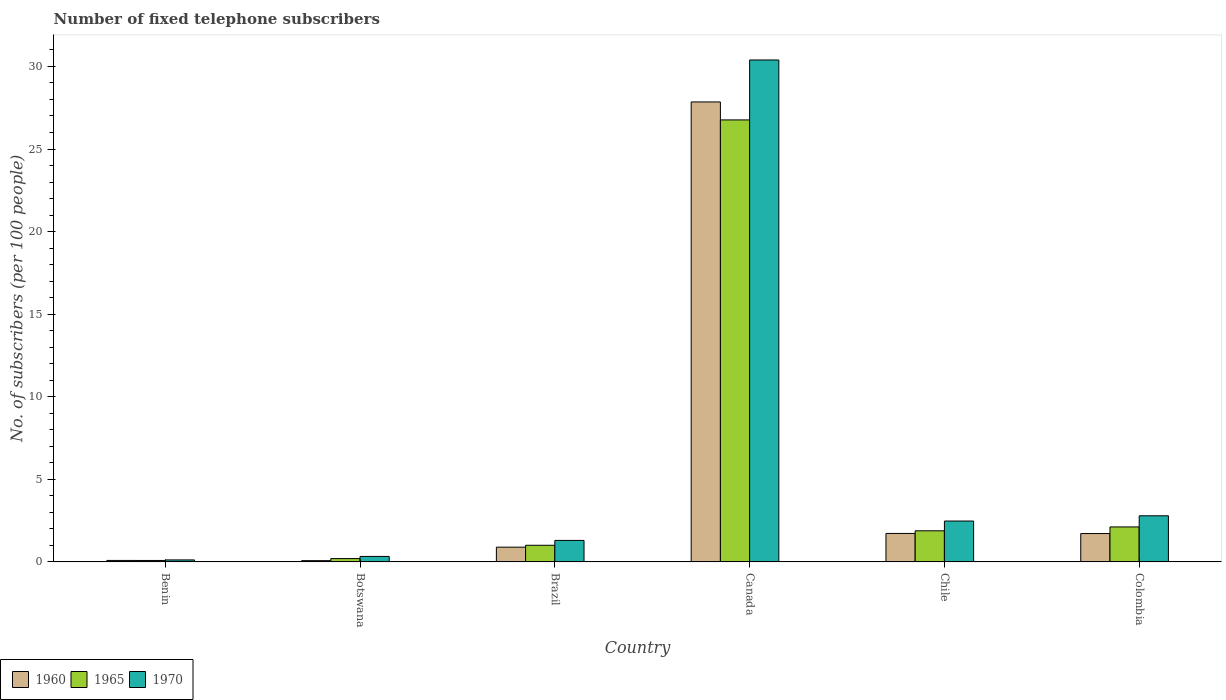How many bars are there on the 4th tick from the right?
Your response must be concise. 3. In how many cases, is the number of bars for a given country not equal to the number of legend labels?
Your answer should be very brief. 0. What is the number of fixed telephone subscribers in 1965 in Benin?
Your response must be concise. 0.09. Across all countries, what is the maximum number of fixed telephone subscribers in 1970?
Offer a very short reply. 30.39. Across all countries, what is the minimum number of fixed telephone subscribers in 1970?
Ensure brevity in your answer.  0.12. In which country was the number of fixed telephone subscribers in 1965 maximum?
Your response must be concise. Canada. In which country was the number of fixed telephone subscribers in 1970 minimum?
Provide a short and direct response. Benin. What is the total number of fixed telephone subscribers in 1965 in the graph?
Provide a short and direct response. 32.06. What is the difference between the number of fixed telephone subscribers in 1965 in Brazil and that in Colombia?
Offer a very short reply. -1.11. What is the difference between the number of fixed telephone subscribers in 1965 in Brazil and the number of fixed telephone subscribers in 1960 in Benin?
Give a very brief answer. 0.92. What is the average number of fixed telephone subscribers in 1970 per country?
Your answer should be very brief. 6.24. What is the difference between the number of fixed telephone subscribers of/in 1970 and number of fixed telephone subscribers of/in 1965 in Colombia?
Keep it short and to the point. 0.67. In how many countries, is the number of fixed telephone subscribers in 1965 greater than 15?
Your answer should be very brief. 1. What is the ratio of the number of fixed telephone subscribers in 1965 in Benin to that in Chile?
Offer a very short reply. 0.05. Is the number of fixed telephone subscribers in 1960 in Benin less than that in Chile?
Ensure brevity in your answer.  Yes. Is the difference between the number of fixed telephone subscribers in 1970 in Canada and Chile greater than the difference between the number of fixed telephone subscribers in 1965 in Canada and Chile?
Keep it short and to the point. Yes. What is the difference between the highest and the second highest number of fixed telephone subscribers in 1970?
Your response must be concise. 0.32. What is the difference between the highest and the lowest number of fixed telephone subscribers in 1965?
Offer a very short reply. 26.67. In how many countries, is the number of fixed telephone subscribers in 1960 greater than the average number of fixed telephone subscribers in 1960 taken over all countries?
Provide a short and direct response. 1. Is the sum of the number of fixed telephone subscribers in 1970 in Botswana and Canada greater than the maximum number of fixed telephone subscribers in 1965 across all countries?
Offer a terse response. Yes. What does the 1st bar from the left in Botswana represents?
Offer a terse response. 1960. How many bars are there?
Ensure brevity in your answer.  18. Are all the bars in the graph horizontal?
Make the answer very short. No. What is the difference between two consecutive major ticks on the Y-axis?
Make the answer very short. 5. What is the title of the graph?
Keep it short and to the point. Number of fixed telephone subscribers. What is the label or title of the Y-axis?
Offer a very short reply. No. of subscribers (per 100 people). What is the No. of subscribers (per 100 people) in 1960 in Benin?
Provide a succinct answer. 0.09. What is the No. of subscribers (per 100 people) of 1965 in Benin?
Provide a succinct answer. 0.09. What is the No. of subscribers (per 100 people) of 1970 in Benin?
Your answer should be compact. 0.12. What is the No. of subscribers (per 100 people) of 1960 in Botswana?
Provide a short and direct response. 0.08. What is the No. of subscribers (per 100 people) in 1965 in Botswana?
Provide a succinct answer. 0.2. What is the No. of subscribers (per 100 people) in 1970 in Botswana?
Offer a very short reply. 0.33. What is the No. of subscribers (per 100 people) of 1960 in Brazil?
Ensure brevity in your answer.  0.89. What is the No. of subscribers (per 100 people) in 1965 in Brazil?
Your response must be concise. 1.01. What is the No. of subscribers (per 100 people) in 1970 in Brazil?
Keep it short and to the point. 1.3. What is the No. of subscribers (per 100 people) of 1960 in Canada?
Provide a succinct answer. 27.85. What is the No. of subscribers (per 100 people) in 1965 in Canada?
Offer a very short reply. 26.76. What is the No. of subscribers (per 100 people) in 1970 in Canada?
Your answer should be very brief. 30.39. What is the No. of subscribers (per 100 people) in 1960 in Chile?
Provide a short and direct response. 1.72. What is the No. of subscribers (per 100 people) of 1965 in Chile?
Your answer should be very brief. 1.88. What is the No. of subscribers (per 100 people) in 1970 in Chile?
Your response must be concise. 2.47. What is the No. of subscribers (per 100 people) of 1960 in Colombia?
Offer a very short reply. 1.72. What is the No. of subscribers (per 100 people) of 1965 in Colombia?
Provide a short and direct response. 2.12. What is the No. of subscribers (per 100 people) of 1970 in Colombia?
Provide a succinct answer. 2.79. Across all countries, what is the maximum No. of subscribers (per 100 people) of 1960?
Make the answer very short. 27.85. Across all countries, what is the maximum No. of subscribers (per 100 people) in 1965?
Your response must be concise. 26.76. Across all countries, what is the maximum No. of subscribers (per 100 people) of 1970?
Provide a succinct answer. 30.39. Across all countries, what is the minimum No. of subscribers (per 100 people) of 1960?
Ensure brevity in your answer.  0.08. Across all countries, what is the minimum No. of subscribers (per 100 people) in 1965?
Your answer should be compact. 0.09. Across all countries, what is the minimum No. of subscribers (per 100 people) in 1970?
Your answer should be very brief. 0.12. What is the total No. of subscribers (per 100 people) in 1960 in the graph?
Give a very brief answer. 32.35. What is the total No. of subscribers (per 100 people) of 1965 in the graph?
Give a very brief answer. 32.06. What is the total No. of subscribers (per 100 people) of 1970 in the graph?
Offer a terse response. 37.41. What is the difference between the No. of subscribers (per 100 people) of 1960 in Benin and that in Botswana?
Provide a succinct answer. 0.01. What is the difference between the No. of subscribers (per 100 people) in 1965 in Benin and that in Botswana?
Offer a terse response. -0.11. What is the difference between the No. of subscribers (per 100 people) of 1970 in Benin and that in Botswana?
Provide a short and direct response. -0.21. What is the difference between the No. of subscribers (per 100 people) in 1960 in Benin and that in Brazil?
Keep it short and to the point. -0.8. What is the difference between the No. of subscribers (per 100 people) in 1965 in Benin and that in Brazil?
Ensure brevity in your answer.  -0.92. What is the difference between the No. of subscribers (per 100 people) of 1970 in Benin and that in Brazil?
Give a very brief answer. -1.18. What is the difference between the No. of subscribers (per 100 people) of 1960 in Benin and that in Canada?
Make the answer very short. -27.76. What is the difference between the No. of subscribers (per 100 people) in 1965 in Benin and that in Canada?
Keep it short and to the point. -26.67. What is the difference between the No. of subscribers (per 100 people) in 1970 in Benin and that in Canada?
Your response must be concise. -30.27. What is the difference between the No. of subscribers (per 100 people) of 1960 in Benin and that in Chile?
Keep it short and to the point. -1.63. What is the difference between the No. of subscribers (per 100 people) in 1965 in Benin and that in Chile?
Make the answer very short. -1.8. What is the difference between the No. of subscribers (per 100 people) in 1970 in Benin and that in Chile?
Offer a very short reply. -2.35. What is the difference between the No. of subscribers (per 100 people) of 1960 in Benin and that in Colombia?
Provide a succinct answer. -1.63. What is the difference between the No. of subscribers (per 100 people) in 1965 in Benin and that in Colombia?
Provide a short and direct response. -2.03. What is the difference between the No. of subscribers (per 100 people) in 1970 in Benin and that in Colombia?
Give a very brief answer. -2.67. What is the difference between the No. of subscribers (per 100 people) in 1960 in Botswana and that in Brazil?
Make the answer very short. -0.82. What is the difference between the No. of subscribers (per 100 people) of 1965 in Botswana and that in Brazil?
Provide a succinct answer. -0.81. What is the difference between the No. of subscribers (per 100 people) of 1970 in Botswana and that in Brazil?
Your answer should be very brief. -0.97. What is the difference between the No. of subscribers (per 100 people) of 1960 in Botswana and that in Canada?
Your answer should be very brief. -27.77. What is the difference between the No. of subscribers (per 100 people) of 1965 in Botswana and that in Canada?
Give a very brief answer. -26.56. What is the difference between the No. of subscribers (per 100 people) of 1970 in Botswana and that in Canada?
Your response must be concise. -30.06. What is the difference between the No. of subscribers (per 100 people) of 1960 in Botswana and that in Chile?
Ensure brevity in your answer.  -1.65. What is the difference between the No. of subscribers (per 100 people) of 1965 in Botswana and that in Chile?
Offer a terse response. -1.68. What is the difference between the No. of subscribers (per 100 people) in 1970 in Botswana and that in Chile?
Offer a terse response. -2.14. What is the difference between the No. of subscribers (per 100 people) of 1960 in Botswana and that in Colombia?
Offer a very short reply. -1.64. What is the difference between the No. of subscribers (per 100 people) of 1965 in Botswana and that in Colombia?
Provide a succinct answer. -1.92. What is the difference between the No. of subscribers (per 100 people) in 1970 in Botswana and that in Colombia?
Make the answer very short. -2.46. What is the difference between the No. of subscribers (per 100 people) in 1960 in Brazil and that in Canada?
Provide a short and direct response. -26.96. What is the difference between the No. of subscribers (per 100 people) in 1965 in Brazil and that in Canada?
Your response must be concise. -25.75. What is the difference between the No. of subscribers (per 100 people) of 1970 in Brazil and that in Canada?
Make the answer very short. -29.09. What is the difference between the No. of subscribers (per 100 people) in 1960 in Brazil and that in Chile?
Provide a succinct answer. -0.83. What is the difference between the No. of subscribers (per 100 people) of 1965 in Brazil and that in Chile?
Give a very brief answer. -0.88. What is the difference between the No. of subscribers (per 100 people) of 1970 in Brazil and that in Chile?
Give a very brief answer. -1.17. What is the difference between the No. of subscribers (per 100 people) of 1960 in Brazil and that in Colombia?
Ensure brevity in your answer.  -0.82. What is the difference between the No. of subscribers (per 100 people) of 1965 in Brazil and that in Colombia?
Give a very brief answer. -1.11. What is the difference between the No. of subscribers (per 100 people) in 1970 in Brazil and that in Colombia?
Provide a succinct answer. -1.49. What is the difference between the No. of subscribers (per 100 people) of 1960 in Canada and that in Chile?
Your answer should be compact. 26.13. What is the difference between the No. of subscribers (per 100 people) of 1965 in Canada and that in Chile?
Make the answer very short. 24.88. What is the difference between the No. of subscribers (per 100 people) of 1970 in Canada and that in Chile?
Offer a very short reply. 27.92. What is the difference between the No. of subscribers (per 100 people) of 1960 in Canada and that in Colombia?
Provide a short and direct response. 26.13. What is the difference between the No. of subscribers (per 100 people) in 1965 in Canada and that in Colombia?
Ensure brevity in your answer.  24.64. What is the difference between the No. of subscribers (per 100 people) of 1970 in Canada and that in Colombia?
Provide a short and direct response. 27.6. What is the difference between the No. of subscribers (per 100 people) in 1960 in Chile and that in Colombia?
Provide a short and direct response. 0.01. What is the difference between the No. of subscribers (per 100 people) in 1965 in Chile and that in Colombia?
Your answer should be compact. -0.23. What is the difference between the No. of subscribers (per 100 people) in 1970 in Chile and that in Colombia?
Give a very brief answer. -0.32. What is the difference between the No. of subscribers (per 100 people) in 1960 in Benin and the No. of subscribers (per 100 people) in 1965 in Botswana?
Make the answer very short. -0.11. What is the difference between the No. of subscribers (per 100 people) of 1960 in Benin and the No. of subscribers (per 100 people) of 1970 in Botswana?
Your response must be concise. -0.24. What is the difference between the No. of subscribers (per 100 people) of 1965 in Benin and the No. of subscribers (per 100 people) of 1970 in Botswana?
Offer a very short reply. -0.24. What is the difference between the No. of subscribers (per 100 people) in 1960 in Benin and the No. of subscribers (per 100 people) in 1965 in Brazil?
Your answer should be compact. -0.92. What is the difference between the No. of subscribers (per 100 people) of 1960 in Benin and the No. of subscribers (per 100 people) of 1970 in Brazil?
Your answer should be compact. -1.21. What is the difference between the No. of subscribers (per 100 people) of 1965 in Benin and the No. of subscribers (per 100 people) of 1970 in Brazil?
Provide a succinct answer. -1.21. What is the difference between the No. of subscribers (per 100 people) of 1960 in Benin and the No. of subscribers (per 100 people) of 1965 in Canada?
Give a very brief answer. -26.67. What is the difference between the No. of subscribers (per 100 people) in 1960 in Benin and the No. of subscribers (per 100 people) in 1970 in Canada?
Make the answer very short. -30.3. What is the difference between the No. of subscribers (per 100 people) in 1965 in Benin and the No. of subscribers (per 100 people) in 1970 in Canada?
Offer a very short reply. -30.3. What is the difference between the No. of subscribers (per 100 people) in 1960 in Benin and the No. of subscribers (per 100 people) in 1965 in Chile?
Your response must be concise. -1.79. What is the difference between the No. of subscribers (per 100 people) of 1960 in Benin and the No. of subscribers (per 100 people) of 1970 in Chile?
Make the answer very short. -2.38. What is the difference between the No. of subscribers (per 100 people) in 1965 in Benin and the No. of subscribers (per 100 people) in 1970 in Chile?
Give a very brief answer. -2.39. What is the difference between the No. of subscribers (per 100 people) of 1960 in Benin and the No. of subscribers (per 100 people) of 1965 in Colombia?
Your response must be concise. -2.03. What is the difference between the No. of subscribers (per 100 people) in 1960 in Benin and the No. of subscribers (per 100 people) in 1970 in Colombia?
Offer a terse response. -2.7. What is the difference between the No. of subscribers (per 100 people) in 1965 in Benin and the No. of subscribers (per 100 people) in 1970 in Colombia?
Keep it short and to the point. -2.7. What is the difference between the No. of subscribers (per 100 people) of 1960 in Botswana and the No. of subscribers (per 100 people) of 1965 in Brazil?
Offer a very short reply. -0.93. What is the difference between the No. of subscribers (per 100 people) in 1960 in Botswana and the No. of subscribers (per 100 people) in 1970 in Brazil?
Offer a very short reply. -1.23. What is the difference between the No. of subscribers (per 100 people) of 1965 in Botswana and the No. of subscribers (per 100 people) of 1970 in Brazil?
Offer a terse response. -1.1. What is the difference between the No. of subscribers (per 100 people) of 1960 in Botswana and the No. of subscribers (per 100 people) of 1965 in Canada?
Give a very brief answer. -26.69. What is the difference between the No. of subscribers (per 100 people) of 1960 in Botswana and the No. of subscribers (per 100 people) of 1970 in Canada?
Offer a very short reply. -30.31. What is the difference between the No. of subscribers (per 100 people) in 1965 in Botswana and the No. of subscribers (per 100 people) in 1970 in Canada?
Make the answer very short. -30.19. What is the difference between the No. of subscribers (per 100 people) of 1960 in Botswana and the No. of subscribers (per 100 people) of 1965 in Chile?
Give a very brief answer. -1.81. What is the difference between the No. of subscribers (per 100 people) in 1960 in Botswana and the No. of subscribers (per 100 people) in 1970 in Chile?
Provide a succinct answer. -2.4. What is the difference between the No. of subscribers (per 100 people) in 1965 in Botswana and the No. of subscribers (per 100 people) in 1970 in Chile?
Keep it short and to the point. -2.27. What is the difference between the No. of subscribers (per 100 people) in 1960 in Botswana and the No. of subscribers (per 100 people) in 1965 in Colombia?
Offer a very short reply. -2.04. What is the difference between the No. of subscribers (per 100 people) of 1960 in Botswana and the No. of subscribers (per 100 people) of 1970 in Colombia?
Give a very brief answer. -2.72. What is the difference between the No. of subscribers (per 100 people) of 1965 in Botswana and the No. of subscribers (per 100 people) of 1970 in Colombia?
Provide a short and direct response. -2.59. What is the difference between the No. of subscribers (per 100 people) of 1960 in Brazil and the No. of subscribers (per 100 people) of 1965 in Canada?
Provide a short and direct response. -25.87. What is the difference between the No. of subscribers (per 100 people) of 1960 in Brazil and the No. of subscribers (per 100 people) of 1970 in Canada?
Offer a very short reply. -29.5. What is the difference between the No. of subscribers (per 100 people) of 1965 in Brazil and the No. of subscribers (per 100 people) of 1970 in Canada?
Provide a succinct answer. -29.38. What is the difference between the No. of subscribers (per 100 people) in 1960 in Brazil and the No. of subscribers (per 100 people) in 1965 in Chile?
Your response must be concise. -0.99. What is the difference between the No. of subscribers (per 100 people) in 1960 in Brazil and the No. of subscribers (per 100 people) in 1970 in Chile?
Ensure brevity in your answer.  -1.58. What is the difference between the No. of subscribers (per 100 people) in 1965 in Brazil and the No. of subscribers (per 100 people) in 1970 in Chile?
Your answer should be compact. -1.47. What is the difference between the No. of subscribers (per 100 people) of 1960 in Brazil and the No. of subscribers (per 100 people) of 1965 in Colombia?
Offer a very short reply. -1.22. What is the difference between the No. of subscribers (per 100 people) of 1960 in Brazil and the No. of subscribers (per 100 people) of 1970 in Colombia?
Offer a very short reply. -1.9. What is the difference between the No. of subscribers (per 100 people) of 1965 in Brazil and the No. of subscribers (per 100 people) of 1970 in Colombia?
Keep it short and to the point. -1.78. What is the difference between the No. of subscribers (per 100 people) of 1960 in Canada and the No. of subscribers (per 100 people) of 1965 in Chile?
Make the answer very short. 25.97. What is the difference between the No. of subscribers (per 100 people) of 1960 in Canada and the No. of subscribers (per 100 people) of 1970 in Chile?
Your response must be concise. 25.37. What is the difference between the No. of subscribers (per 100 people) in 1965 in Canada and the No. of subscribers (per 100 people) in 1970 in Chile?
Offer a very short reply. 24.29. What is the difference between the No. of subscribers (per 100 people) in 1960 in Canada and the No. of subscribers (per 100 people) in 1965 in Colombia?
Ensure brevity in your answer.  25.73. What is the difference between the No. of subscribers (per 100 people) of 1960 in Canada and the No. of subscribers (per 100 people) of 1970 in Colombia?
Provide a succinct answer. 25.06. What is the difference between the No. of subscribers (per 100 people) of 1965 in Canada and the No. of subscribers (per 100 people) of 1970 in Colombia?
Your answer should be very brief. 23.97. What is the difference between the No. of subscribers (per 100 people) of 1960 in Chile and the No. of subscribers (per 100 people) of 1965 in Colombia?
Offer a very short reply. -0.39. What is the difference between the No. of subscribers (per 100 people) in 1960 in Chile and the No. of subscribers (per 100 people) in 1970 in Colombia?
Your response must be concise. -1.07. What is the difference between the No. of subscribers (per 100 people) of 1965 in Chile and the No. of subscribers (per 100 people) of 1970 in Colombia?
Make the answer very short. -0.91. What is the average No. of subscribers (per 100 people) of 1960 per country?
Provide a succinct answer. 5.39. What is the average No. of subscribers (per 100 people) in 1965 per country?
Offer a terse response. 5.34. What is the average No. of subscribers (per 100 people) of 1970 per country?
Ensure brevity in your answer.  6.24. What is the difference between the No. of subscribers (per 100 people) in 1960 and No. of subscribers (per 100 people) in 1965 in Benin?
Provide a succinct answer. 0. What is the difference between the No. of subscribers (per 100 people) of 1960 and No. of subscribers (per 100 people) of 1970 in Benin?
Your answer should be very brief. -0.03. What is the difference between the No. of subscribers (per 100 people) in 1965 and No. of subscribers (per 100 people) in 1970 in Benin?
Offer a very short reply. -0.03. What is the difference between the No. of subscribers (per 100 people) in 1960 and No. of subscribers (per 100 people) in 1965 in Botswana?
Offer a terse response. -0.13. What is the difference between the No. of subscribers (per 100 people) in 1960 and No. of subscribers (per 100 people) in 1970 in Botswana?
Offer a terse response. -0.26. What is the difference between the No. of subscribers (per 100 people) of 1965 and No. of subscribers (per 100 people) of 1970 in Botswana?
Provide a succinct answer. -0.13. What is the difference between the No. of subscribers (per 100 people) of 1960 and No. of subscribers (per 100 people) of 1965 in Brazil?
Provide a short and direct response. -0.11. What is the difference between the No. of subscribers (per 100 people) in 1960 and No. of subscribers (per 100 people) in 1970 in Brazil?
Your answer should be compact. -0.41. What is the difference between the No. of subscribers (per 100 people) in 1965 and No. of subscribers (per 100 people) in 1970 in Brazil?
Provide a short and direct response. -0.29. What is the difference between the No. of subscribers (per 100 people) of 1960 and No. of subscribers (per 100 people) of 1965 in Canada?
Keep it short and to the point. 1.09. What is the difference between the No. of subscribers (per 100 people) of 1960 and No. of subscribers (per 100 people) of 1970 in Canada?
Give a very brief answer. -2.54. What is the difference between the No. of subscribers (per 100 people) of 1965 and No. of subscribers (per 100 people) of 1970 in Canada?
Offer a very short reply. -3.63. What is the difference between the No. of subscribers (per 100 people) of 1960 and No. of subscribers (per 100 people) of 1965 in Chile?
Ensure brevity in your answer.  -0.16. What is the difference between the No. of subscribers (per 100 people) in 1960 and No. of subscribers (per 100 people) in 1970 in Chile?
Your response must be concise. -0.75. What is the difference between the No. of subscribers (per 100 people) in 1965 and No. of subscribers (per 100 people) in 1970 in Chile?
Give a very brief answer. -0.59. What is the difference between the No. of subscribers (per 100 people) of 1960 and No. of subscribers (per 100 people) of 1965 in Colombia?
Offer a terse response. -0.4. What is the difference between the No. of subscribers (per 100 people) in 1960 and No. of subscribers (per 100 people) in 1970 in Colombia?
Offer a very short reply. -1.07. What is the difference between the No. of subscribers (per 100 people) in 1965 and No. of subscribers (per 100 people) in 1970 in Colombia?
Offer a terse response. -0.67. What is the ratio of the No. of subscribers (per 100 people) of 1960 in Benin to that in Botswana?
Ensure brevity in your answer.  1.17. What is the ratio of the No. of subscribers (per 100 people) in 1965 in Benin to that in Botswana?
Give a very brief answer. 0.43. What is the ratio of the No. of subscribers (per 100 people) of 1970 in Benin to that in Botswana?
Offer a terse response. 0.36. What is the ratio of the No. of subscribers (per 100 people) of 1960 in Benin to that in Brazil?
Keep it short and to the point. 0.1. What is the ratio of the No. of subscribers (per 100 people) of 1965 in Benin to that in Brazil?
Offer a terse response. 0.09. What is the ratio of the No. of subscribers (per 100 people) in 1970 in Benin to that in Brazil?
Ensure brevity in your answer.  0.09. What is the ratio of the No. of subscribers (per 100 people) in 1960 in Benin to that in Canada?
Make the answer very short. 0. What is the ratio of the No. of subscribers (per 100 people) in 1965 in Benin to that in Canada?
Give a very brief answer. 0. What is the ratio of the No. of subscribers (per 100 people) in 1970 in Benin to that in Canada?
Provide a succinct answer. 0. What is the ratio of the No. of subscribers (per 100 people) in 1960 in Benin to that in Chile?
Provide a short and direct response. 0.05. What is the ratio of the No. of subscribers (per 100 people) in 1965 in Benin to that in Chile?
Your answer should be very brief. 0.05. What is the ratio of the No. of subscribers (per 100 people) in 1970 in Benin to that in Chile?
Offer a very short reply. 0.05. What is the ratio of the No. of subscribers (per 100 people) in 1960 in Benin to that in Colombia?
Your response must be concise. 0.05. What is the ratio of the No. of subscribers (per 100 people) in 1965 in Benin to that in Colombia?
Give a very brief answer. 0.04. What is the ratio of the No. of subscribers (per 100 people) of 1970 in Benin to that in Colombia?
Offer a very short reply. 0.04. What is the ratio of the No. of subscribers (per 100 people) of 1960 in Botswana to that in Brazil?
Keep it short and to the point. 0.09. What is the ratio of the No. of subscribers (per 100 people) in 1965 in Botswana to that in Brazil?
Ensure brevity in your answer.  0.2. What is the ratio of the No. of subscribers (per 100 people) in 1970 in Botswana to that in Brazil?
Provide a succinct answer. 0.26. What is the ratio of the No. of subscribers (per 100 people) in 1960 in Botswana to that in Canada?
Your response must be concise. 0. What is the ratio of the No. of subscribers (per 100 people) of 1965 in Botswana to that in Canada?
Offer a terse response. 0.01. What is the ratio of the No. of subscribers (per 100 people) of 1970 in Botswana to that in Canada?
Provide a succinct answer. 0.01. What is the ratio of the No. of subscribers (per 100 people) of 1960 in Botswana to that in Chile?
Offer a terse response. 0.04. What is the ratio of the No. of subscribers (per 100 people) in 1965 in Botswana to that in Chile?
Provide a short and direct response. 0.11. What is the ratio of the No. of subscribers (per 100 people) in 1970 in Botswana to that in Chile?
Ensure brevity in your answer.  0.13. What is the ratio of the No. of subscribers (per 100 people) in 1960 in Botswana to that in Colombia?
Offer a terse response. 0.04. What is the ratio of the No. of subscribers (per 100 people) in 1965 in Botswana to that in Colombia?
Your answer should be very brief. 0.1. What is the ratio of the No. of subscribers (per 100 people) of 1970 in Botswana to that in Colombia?
Provide a succinct answer. 0.12. What is the ratio of the No. of subscribers (per 100 people) of 1960 in Brazil to that in Canada?
Ensure brevity in your answer.  0.03. What is the ratio of the No. of subscribers (per 100 people) in 1965 in Brazil to that in Canada?
Offer a terse response. 0.04. What is the ratio of the No. of subscribers (per 100 people) in 1970 in Brazil to that in Canada?
Offer a very short reply. 0.04. What is the ratio of the No. of subscribers (per 100 people) in 1960 in Brazil to that in Chile?
Your answer should be compact. 0.52. What is the ratio of the No. of subscribers (per 100 people) of 1965 in Brazil to that in Chile?
Your answer should be very brief. 0.53. What is the ratio of the No. of subscribers (per 100 people) of 1970 in Brazil to that in Chile?
Keep it short and to the point. 0.53. What is the ratio of the No. of subscribers (per 100 people) of 1960 in Brazil to that in Colombia?
Your answer should be very brief. 0.52. What is the ratio of the No. of subscribers (per 100 people) in 1965 in Brazil to that in Colombia?
Offer a very short reply. 0.48. What is the ratio of the No. of subscribers (per 100 people) in 1970 in Brazil to that in Colombia?
Your response must be concise. 0.47. What is the ratio of the No. of subscribers (per 100 people) of 1960 in Canada to that in Chile?
Offer a very short reply. 16.16. What is the ratio of the No. of subscribers (per 100 people) in 1965 in Canada to that in Chile?
Provide a short and direct response. 14.21. What is the ratio of the No. of subscribers (per 100 people) in 1970 in Canada to that in Chile?
Offer a terse response. 12.28. What is the ratio of the No. of subscribers (per 100 people) in 1960 in Canada to that in Colombia?
Your answer should be compact. 16.21. What is the ratio of the No. of subscribers (per 100 people) of 1965 in Canada to that in Colombia?
Provide a short and direct response. 12.64. What is the ratio of the No. of subscribers (per 100 people) in 1970 in Canada to that in Colombia?
Your answer should be very brief. 10.88. What is the ratio of the No. of subscribers (per 100 people) in 1960 in Chile to that in Colombia?
Offer a very short reply. 1. What is the ratio of the No. of subscribers (per 100 people) in 1965 in Chile to that in Colombia?
Ensure brevity in your answer.  0.89. What is the ratio of the No. of subscribers (per 100 people) in 1970 in Chile to that in Colombia?
Offer a very short reply. 0.89. What is the difference between the highest and the second highest No. of subscribers (per 100 people) of 1960?
Keep it short and to the point. 26.13. What is the difference between the highest and the second highest No. of subscribers (per 100 people) of 1965?
Keep it short and to the point. 24.64. What is the difference between the highest and the second highest No. of subscribers (per 100 people) in 1970?
Offer a very short reply. 27.6. What is the difference between the highest and the lowest No. of subscribers (per 100 people) in 1960?
Your response must be concise. 27.77. What is the difference between the highest and the lowest No. of subscribers (per 100 people) in 1965?
Your answer should be compact. 26.67. What is the difference between the highest and the lowest No. of subscribers (per 100 people) in 1970?
Your answer should be very brief. 30.27. 